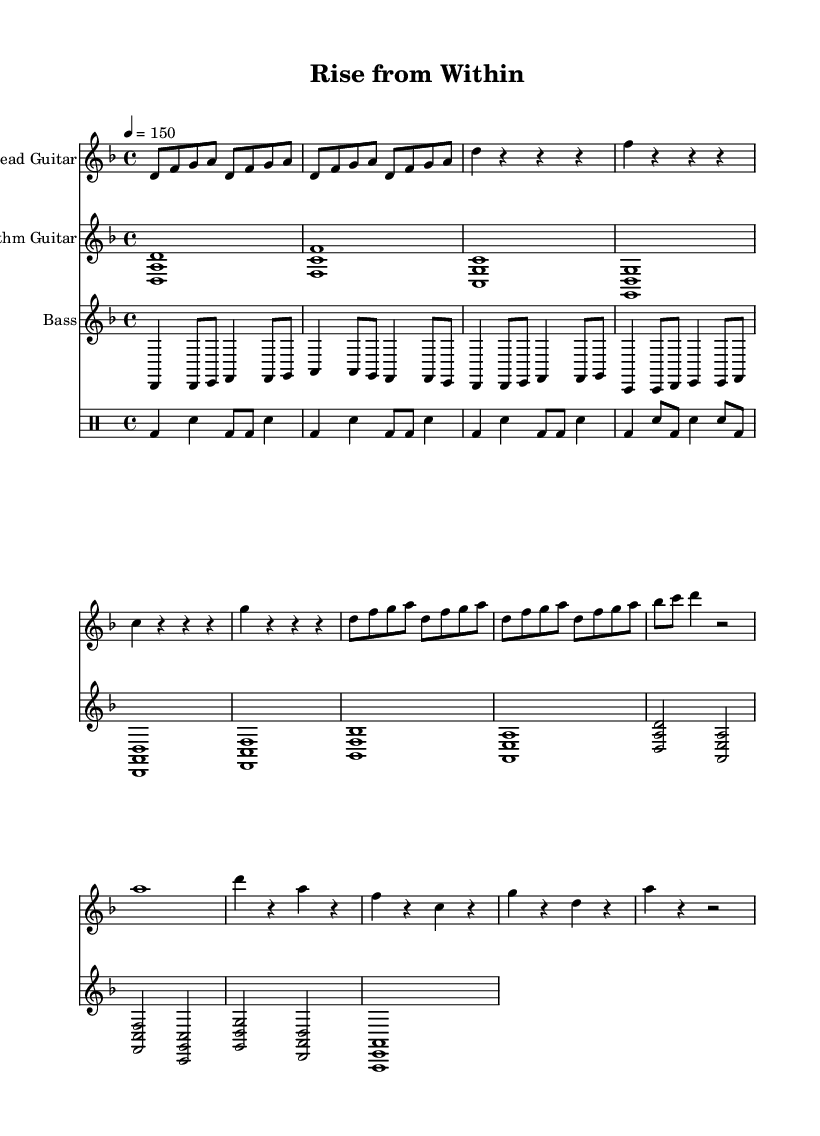What is the key signature of this music? The key signature is D minor, which has one flat (B flat). This is indicated at the beginning of the sheet music.
Answer: D minor What is the time signature of this music? The time signature is 4/4, which means there are four beats per measure, and the quarter note gets one beat. This is shown in the opening of the sheet music.
Answer: 4/4 What is the tempo marking for this piece? The tempo marking is quarter note equals 150. This means that each quarter note should be played at a speed of 150 beats per minute. This is listed in the global settings.
Answer: 150 How many parts are there in this score? There are four parts in the score: Lead Guitar, Rhythm Guitar, Bass, and Drums. Each part is indicated with a separate staff for clarity in the sheet music.
Answer: Four What type of guitar technique is suggested in the lead guitar part during the intro? The lead guitar part consists of straight eighth notes during the intro, implying a consistent rhythmic pattern typical of metal music. This is evident from the note values presented in that section.
Answer: Eighth notes How is the bridge section of the song structured? The bridge section features a mix of longer note values and rests, creating a contrasting feel compared to the verses and chorus. Each measure consists of a combination of quarter notes and rests, highlighting a shift in dynamics.
Answer: Mixed rhythms 